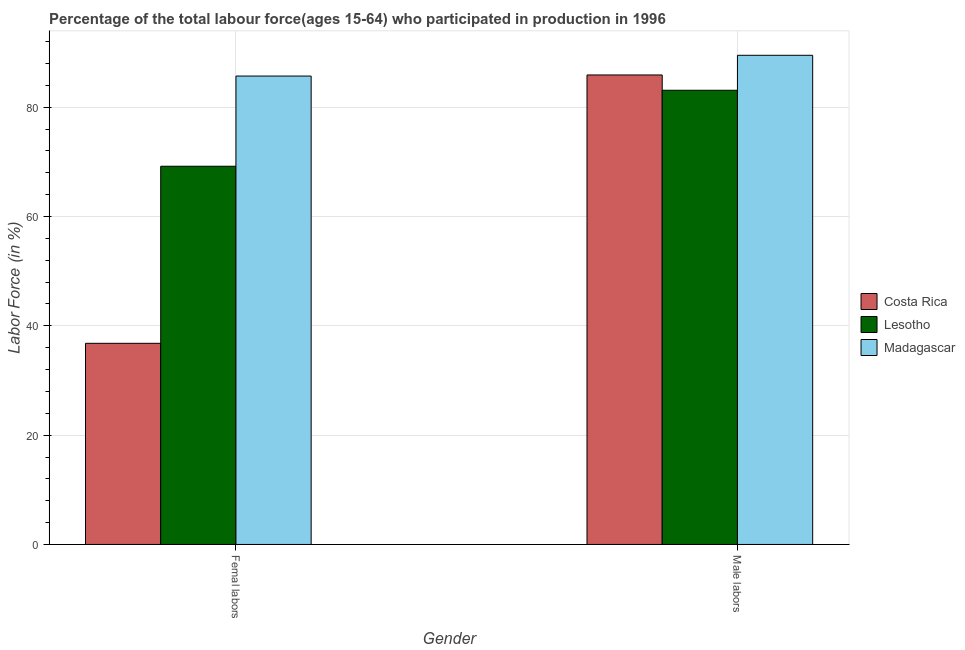How many groups of bars are there?
Provide a short and direct response. 2. How many bars are there on the 1st tick from the left?
Ensure brevity in your answer.  3. What is the label of the 2nd group of bars from the left?
Offer a terse response. Male labors. What is the percentage of male labour force in Costa Rica?
Make the answer very short. 85.9. Across all countries, what is the maximum percentage of female labor force?
Keep it short and to the point. 85.7. Across all countries, what is the minimum percentage of male labour force?
Provide a succinct answer. 83.1. In which country was the percentage of female labor force maximum?
Your answer should be compact. Madagascar. In which country was the percentage of male labour force minimum?
Make the answer very short. Lesotho. What is the total percentage of female labor force in the graph?
Offer a terse response. 191.7. What is the difference between the percentage of female labor force in Lesotho and that in Costa Rica?
Give a very brief answer. 32.4. What is the difference between the percentage of male labour force in Madagascar and the percentage of female labor force in Lesotho?
Your answer should be very brief. 20.3. What is the average percentage of male labour force per country?
Ensure brevity in your answer.  86.17. What is the difference between the percentage of female labor force and percentage of male labour force in Lesotho?
Offer a very short reply. -13.9. In how many countries, is the percentage of female labor force greater than 88 %?
Offer a terse response. 0. What is the ratio of the percentage of female labor force in Lesotho to that in Madagascar?
Your response must be concise. 0.81. Is the percentage of male labour force in Madagascar less than that in Costa Rica?
Your response must be concise. No. What does the 1st bar from the left in Male labors represents?
Make the answer very short. Costa Rica. What does the 1st bar from the right in Femal labors represents?
Give a very brief answer. Madagascar. Does the graph contain any zero values?
Keep it short and to the point. No. Does the graph contain grids?
Ensure brevity in your answer.  Yes. How many legend labels are there?
Make the answer very short. 3. What is the title of the graph?
Your answer should be compact. Percentage of the total labour force(ages 15-64) who participated in production in 1996. What is the Labor Force (in %) in Costa Rica in Femal labors?
Provide a succinct answer. 36.8. What is the Labor Force (in %) in Lesotho in Femal labors?
Give a very brief answer. 69.2. What is the Labor Force (in %) in Madagascar in Femal labors?
Make the answer very short. 85.7. What is the Labor Force (in %) of Costa Rica in Male labors?
Make the answer very short. 85.9. What is the Labor Force (in %) in Lesotho in Male labors?
Your answer should be very brief. 83.1. What is the Labor Force (in %) of Madagascar in Male labors?
Keep it short and to the point. 89.5. Across all Gender, what is the maximum Labor Force (in %) in Costa Rica?
Ensure brevity in your answer.  85.9. Across all Gender, what is the maximum Labor Force (in %) in Lesotho?
Provide a succinct answer. 83.1. Across all Gender, what is the maximum Labor Force (in %) of Madagascar?
Provide a succinct answer. 89.5. Across all Gender, what is the minimum Labor Force (in %) in Costa Rica?
Offer a terse response. 36.8. Across all Gender, what is the minimum Labor Force (in %) in Lesotho?
Your answer should be very brief. 69.2. Across all Gender, what is the minimum Labor Force (in %) in Madagascar?
Make the answer very short. 85.7. What is the total Labor Force (in %) in Costa Rica in the graph?
Offer a terse response. 122.7. What is the total Labor Force (in %) of Lesotho in the graph?
Offer a very short reply. 152.3. What is the total Labor Force (in %) in Madagascar in the graph?
Offer a very short reply. 175.2. What is the difference between the Labor Force (in %) of Costa Rica in Femal labors and that in Male labors?
Keep it short and to the point. -49.1. What is the difference between the Labor Force (in %) of Costa Rica in Femal labors and the Labor Force (in %) of Lesotho in Male labors?
Ensure brevity in your answer.  -46.3. What is the difference between the Labor Force (in %) in Costa Rica in Femal labors and the Labor Force (in %) in Madagascar in Male labors?
Give a very brief answer. -52.7. What is the difference between the Labor Force (in %) of Lesotho in Femal labors and the Labor Force (in %) of Madagascar in Male labors?
Offer a very short reply. -20.3. What is the average Labor Force (in %) of Costa Rica per Gender?
Your answer should be compact. 61.35. What is the average Labor Force (in %) in Lesotho per Gender?
Make the answer very short. 76.15. What is the average Labor Force (in %) of Madagascar per Gender?
Your answer should be compact. 87.6. What is the difference between the Labor Force (in %) in Costa Rica and Labor Force (in %) in Lesotho in Femal labors?
Give a very brief answer. -32.4. What is the difference between the Labor Force (in %) in Costa Rica and Labor Force (in %) in Madagascar in Femal labors?
Give a very brief answer. -48.9. What is the difference between the Labor Force (in %) in Lesotho and Labor Force (in %) in Madagascar in Femal labors?
Keep it short and to the point. -16.5. What is the difference between the Labor Force (in %) in Costa Rica and Labor Force (in %) in Lesotho in Male labors?
Your answer should be very brief. 2.8. What is the difference between the Labor Force (in %) of Costa Rica and Labor Force (in %) of Madagascar in Male labors?
Your answer should be compact. -3.6. What is the ratio of the Labor Force (in %) of Costa Rica in Femal labors to that in Male labors?
Keep it short and to the point. 0.43. What is the ratio of the Labor Force (in %) in Lesotho in Femal labors to that in Male labors?
Your answer should be compact. 0.83. What is the ratio of the Labor Force (in %) in Madagascar in Femal labors to that in Male labors?
Offer a very short reply. 0.96. What is the difference between the highest and the second highest Labor Force (in %) in Costa Rica?
Provide a succinct answer. 49.1. What is the difference between the highest and the second highest Labor Force (in %) of Madagascar?
Offer a very short reply. 3.8. What is the difference between the highest and the lowest Labor Force (in %) of Costa Rica?
Ensure brevity in your answer.  49.1. What is the difference between the highest and the lowest Labor Force (in %) in Madagascar?
Make the answer very short. 3.8. 